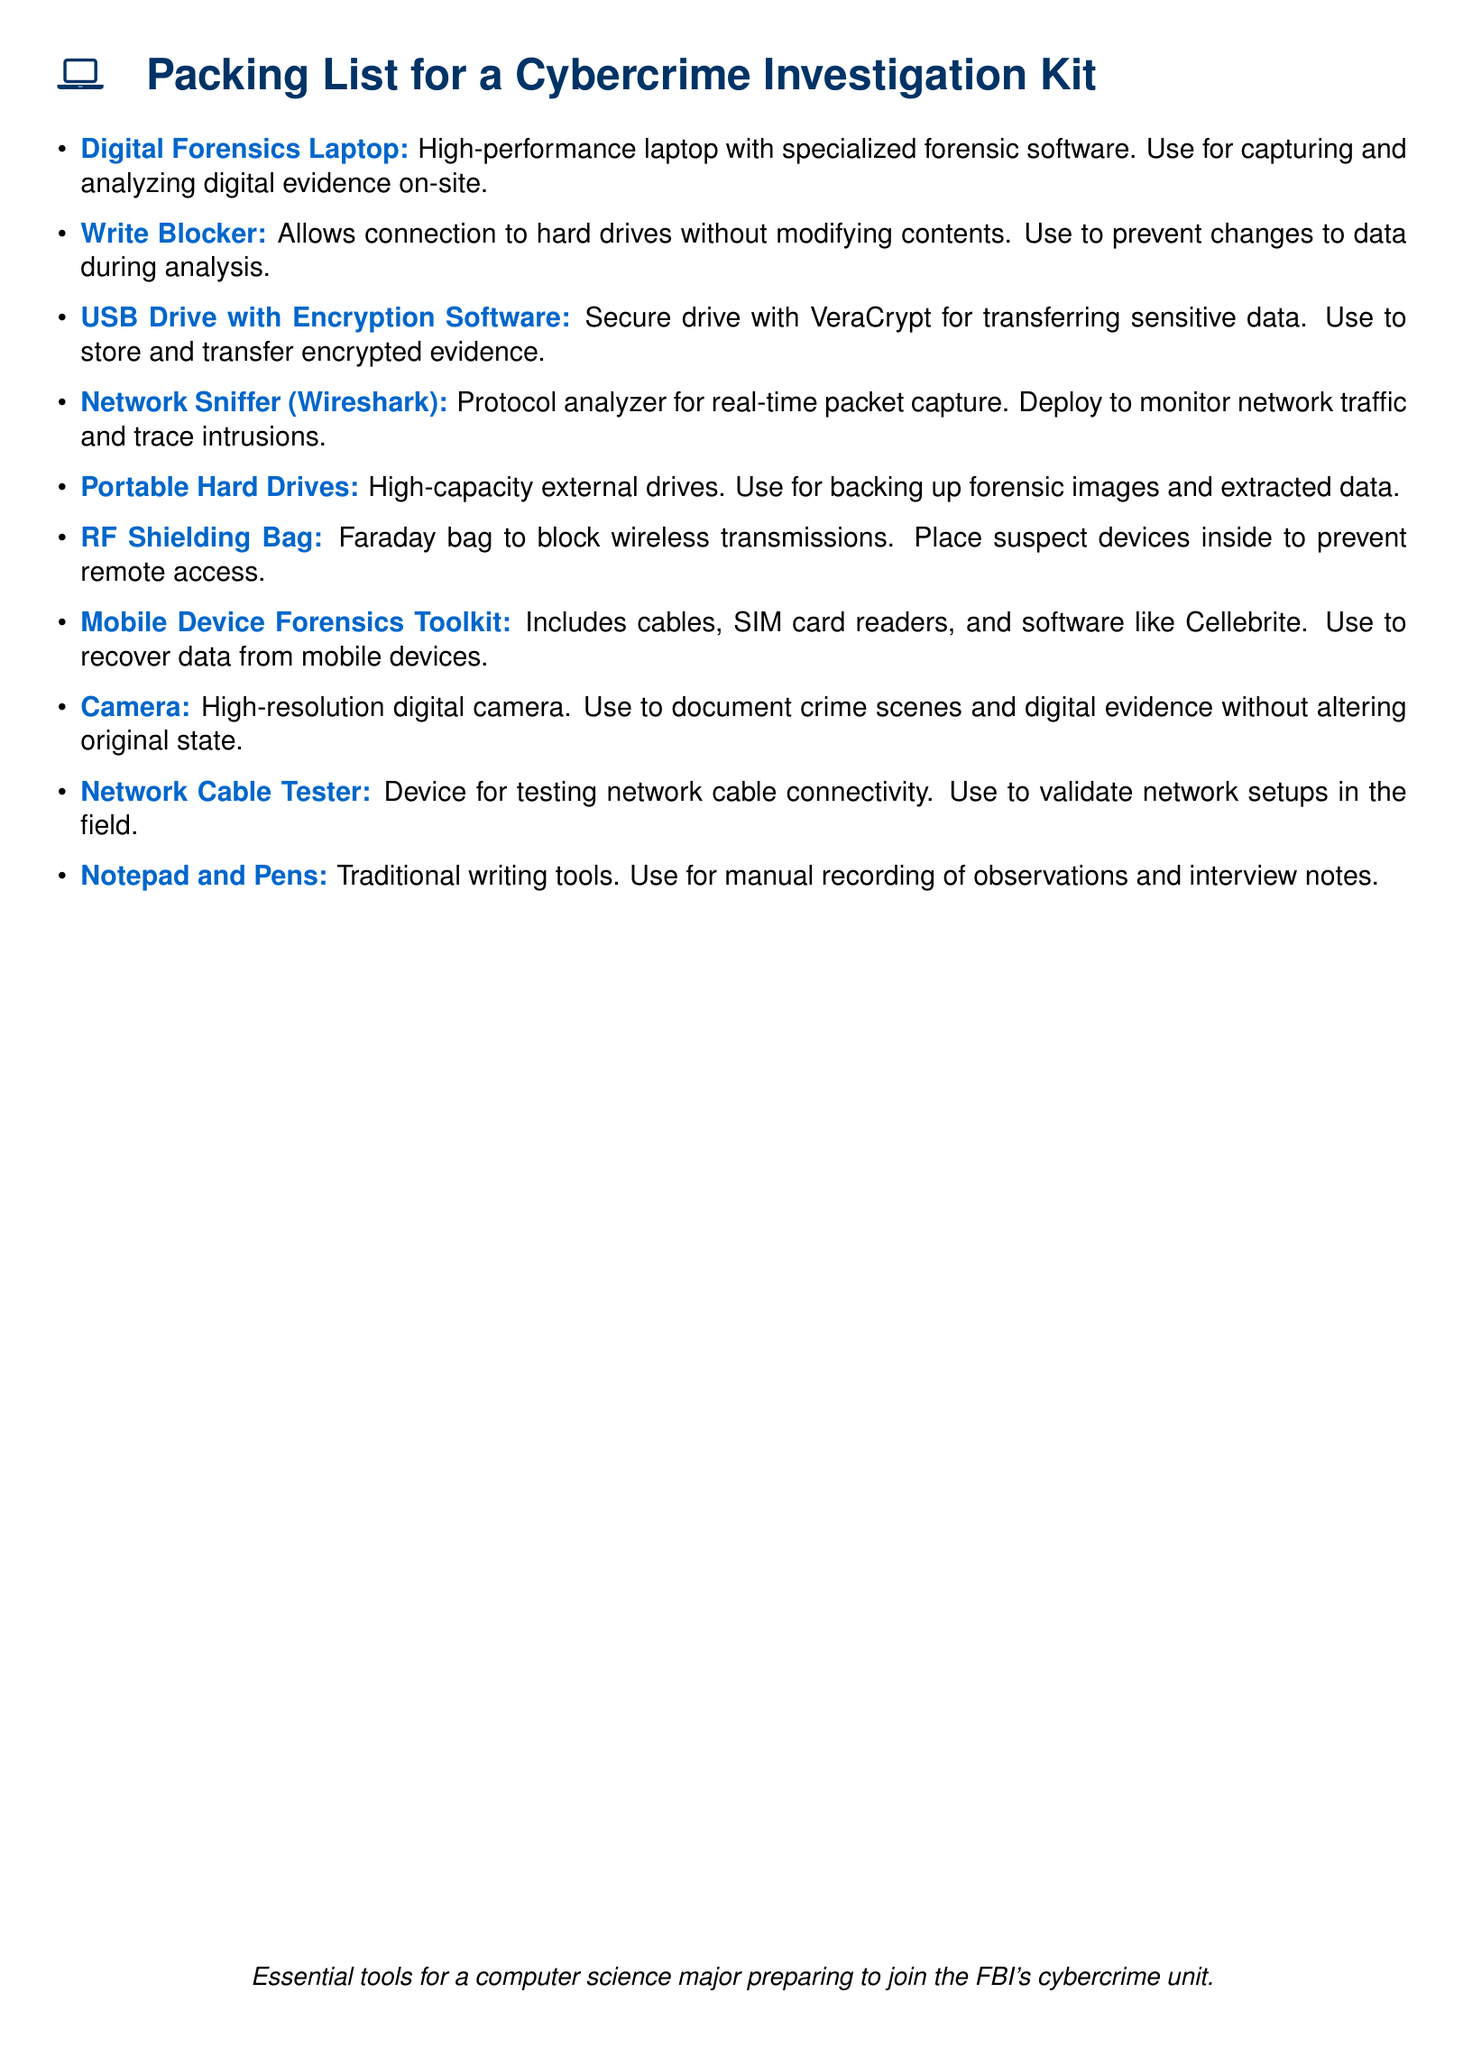what is the title of this document? The title is prominently displayed at the top of the document, which details what the document is about.
Answer: Packing List for a Cybercrime Investigation Kit how many items are listed in the packing list? The number of items can be counted from the bullet points provided in the list.
Answer: Ten what is the purpose of the Write Blocker? The purpose is described within the item description, explaining its function in relation to data integrity.
Answer: Prevent changes to data during analysis what software is used on the Digital Forensics Laptop? The specific mention of specialized software is included in the description for the laptop.
Answer: Forensic software what item is used to document crime scenes? The item that serves this purpose is referenced in the list for its specific functionality.
Answer: Camera what kind of bag is a RF Shielding Bag? The description clarifies the function and type of this particular item listed.
Answer: Faraday bag what is the use of the USB Drive with Encryption Software? The use is outlined, indicating how it relates to data security and evidence handling.
Answer: Store and transfer encrypted evidence what tools are included in the Mobile Device Forensics Toolkit? The description gives an overview of the components included within this toolkit.
Answer: Cables, SIM card readers, and software what is the primary use of the Network Sniffer? The primary use is articulated in the description, relating to network traffic.
Answer: Monitor network traffic how does the Portable Hard Drives aid in an investigation? The description indicates how this item fulfills a critical role in data management during investigations.
Answer: Backing up forensic images and extracted data 